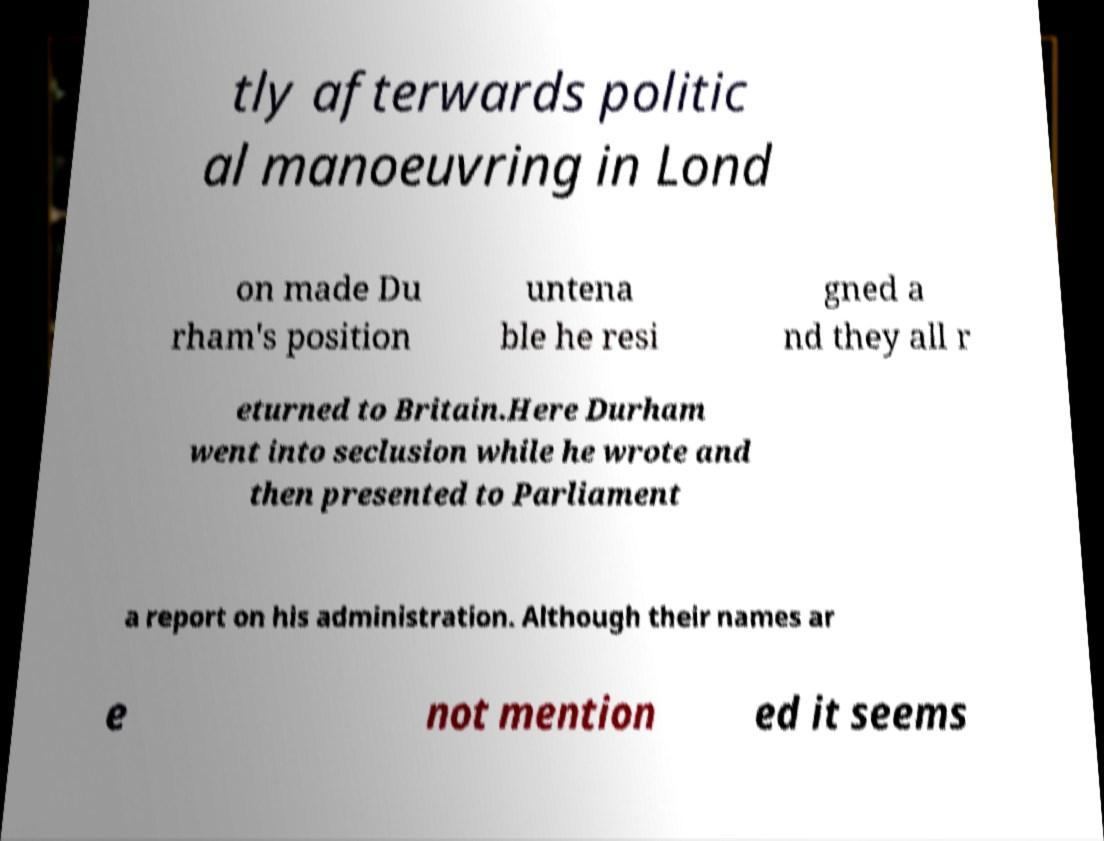Could you assist in decoding the text presented in this image and type it out clearly? tly afterwards politic al manoeuvring in Lond on made Du rham's position untena ble he resi gned a nd they all r eturned to Britain.Here Durham went into seclusion while he wrote and then presented to Parliament a report on his administration. Although their names ar e not mention ed it seems 